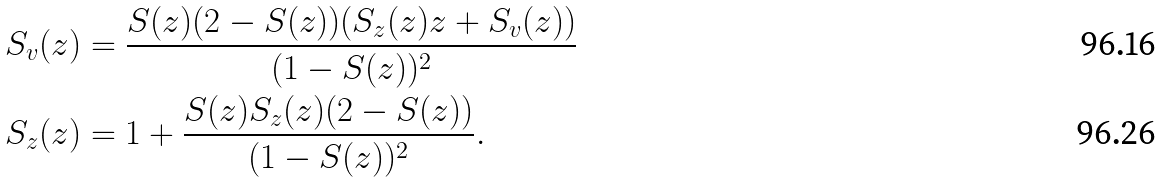Convert formula to latex. <formula><loc_0><loc_0><loc_500><loc_500>S _ { v } ( z ) & = \frac { S ( z ) ( 2 - S ( z ) ) ( S _ { z } ( z ) z + S _ { v } ( z ) ) } { ( 1 - S ( z ) ) ^ { 2 } } \\ S _ { z } ( z ) & = 1 + \frac { S ( z ) S _ { z } ( z ) ( 2 - S ( z ) ) } { ( 1 - S ( z ) ) ^ { 2 } } .</formula> 